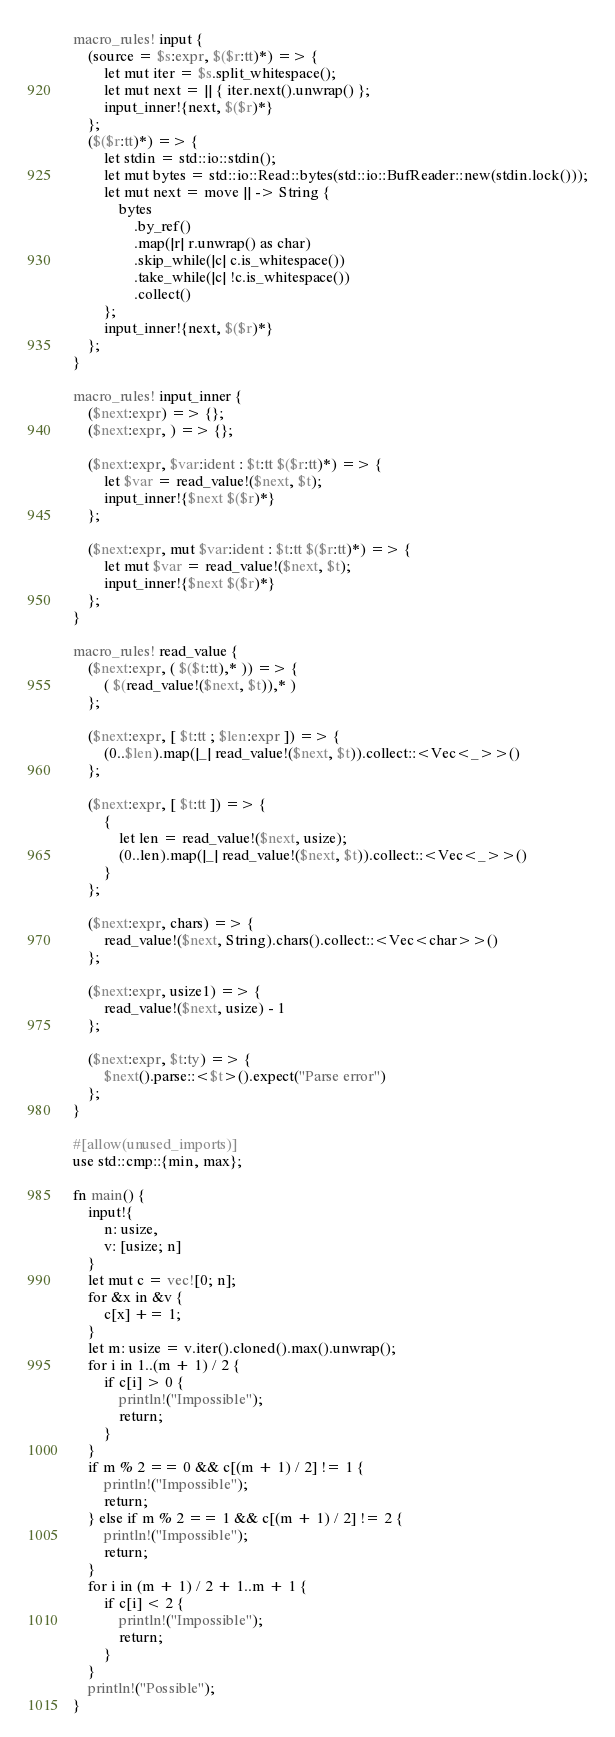Convert code to text. <code><loc_0><loc_0><loc_500><loc_500><_Rust_>macro_rules! input {
    (source = $s:expr, $($r:tt)*) => {
        let mut iter = $s.split_whitespace();
        let mut next = || { iter.next().unwrap() };
        input_inner!{next, $($r)*}
    };
    ($($r:tt)*) => {
        let stdin = std::io::stdin();
        let mut bytes = std::io::Read::bytes(std::io::BufReader::new(stdin.lock()));
        let mut next = move || -> String {
            bytes
                .by_ref()
                .map(|r| r.unwrap() as char)
                .skip_while(|c| c.is_whitespace())
                .take_while(|c| !c.is_whitespace())
                .collect()
        };
        input_inner!{next, $($r)*}
    };
}

macro_rules! input_inner {
    ($next:expr) => {};
    ($next:expr, ) => {};

    ($next:expr, $var:ident : $t:tt $($r:tt)*) => {
        let $var = read_value!($next, $t);
        input_inner!{$next $($r)*}
    };

    ($next:expr, mut $var:ident : $t:tt $($r:tt)*) => {
        let mut $var = read_value!($next, $t);
        input_inner!{$next $($r)*}
    };
}

macro_rules! read_value {
    ($next:expr, ( $($t:tt),* )) => {
        ( $(read_value!($next, $t)),* )
    };

    ($next:expr, [ $t:tt ; $len:expr ]) => {
        (0..$len).map(|_| read_value!($next, $t)).collect::<Vec<_>>()
    };

    ($next:expr, [ $t:tt ]) => {
        {
            let len = read_value!($next, usize);
            (0..len).map(|_| read_value!($next, $t)).collect::<Vec<_>>()
        }
    };

    ($next:expr, chars) => {
        read_value!($next, String).chars().collect::<Vec<char>>()
    };

    ($next:expr, usize1) => {
        read_value!($next, usize) - 1
    };

    ($next:expr, $t:ty) => {
        $next().parse::<$t>().expect("Parse error")
    };
}

#[allow(unused_imports)]
use std::cmp::{min, max};

fn main() {
    input!{
        n: usize,
        v: [usize; n]
    }
    let mut c = vec![0; n];
    for &x in &v {
        c[x] += 1;
    }
    let m: usize = v.iter().cloned().max().unwrap();
    for i in 1..(m + 1) / 2 {
        if c[i] > 0 {
            println!("Impossible");
            return;
        }
    }
    if m % 2 == 0 && c[(m + 1) / 2] != 1 {
        println!("Impossible");
        return;
    } else if m % 2 == 1 && c[(m + 1) / 2] != 2 {
        println!("Impossible");
        return;
    }
    for i in (m + 1) / 2 + 1..m + 1 {
        if c[i] < 2 {
            println!("Impossible");
            return;
        }
    }
    println!("Possible");
}
</code> 